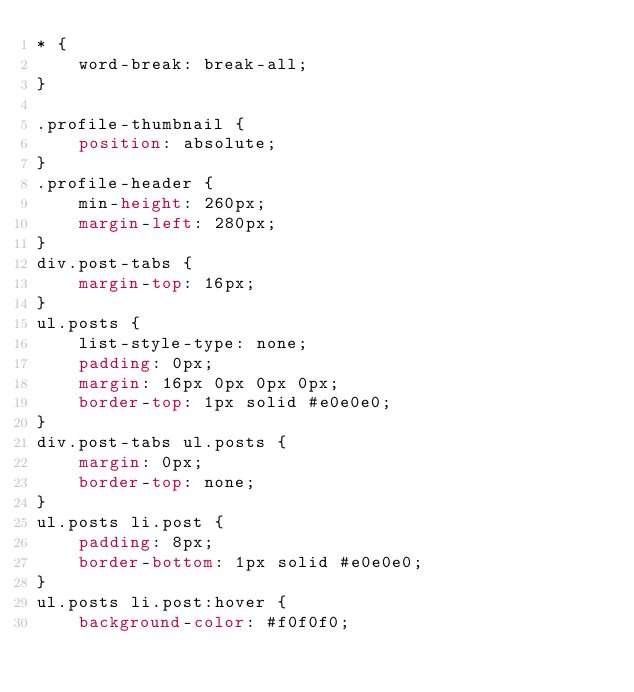Convert code to text. <code><loc_0><loc_0><loc_500><loc_500><_CSS_>* {
    word-break: break-all;
}

.profile-thumbnail {
    position: absolute;
}
.profile-header {
    min-height: 260px;
    margin-left: 280px;
}
div.post-tabs {
    margin-top: 16px;
}
ul.posts {
    list-style-type: none;
    padding: 0px;
    margin: 16px 0px 0px 0px;
    border-top: 1px solid #e0e0e0;
}
div.post-tabs ul.posts {
    margin: 0px;
    border-top: none;
}
ul.posts li.post {
    padding: 8px;
    border-bottom: 1px solid #e0e0e0;
}
ul.posts li.post:hover {
    background-color: #f0f0f0;</code> 